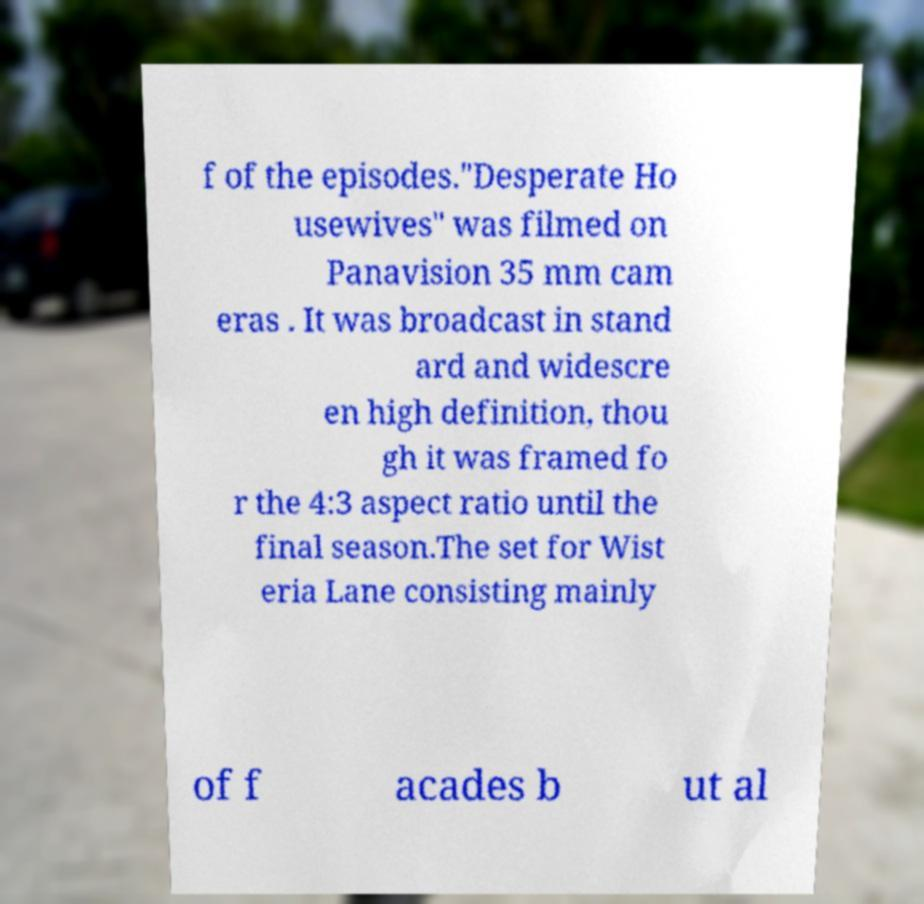Could you extract and type out the text from this image? f of the episodes."Desperate Ho usewives" was filmed on Panavision 35 mm cam eras . It was broadcast in stand ard and widescre en high definition, thou gh it was framed fo r the 4:3 aspect ratio until the final season.The set for Wist eria Lane consisting mainly of f acades b ut al 